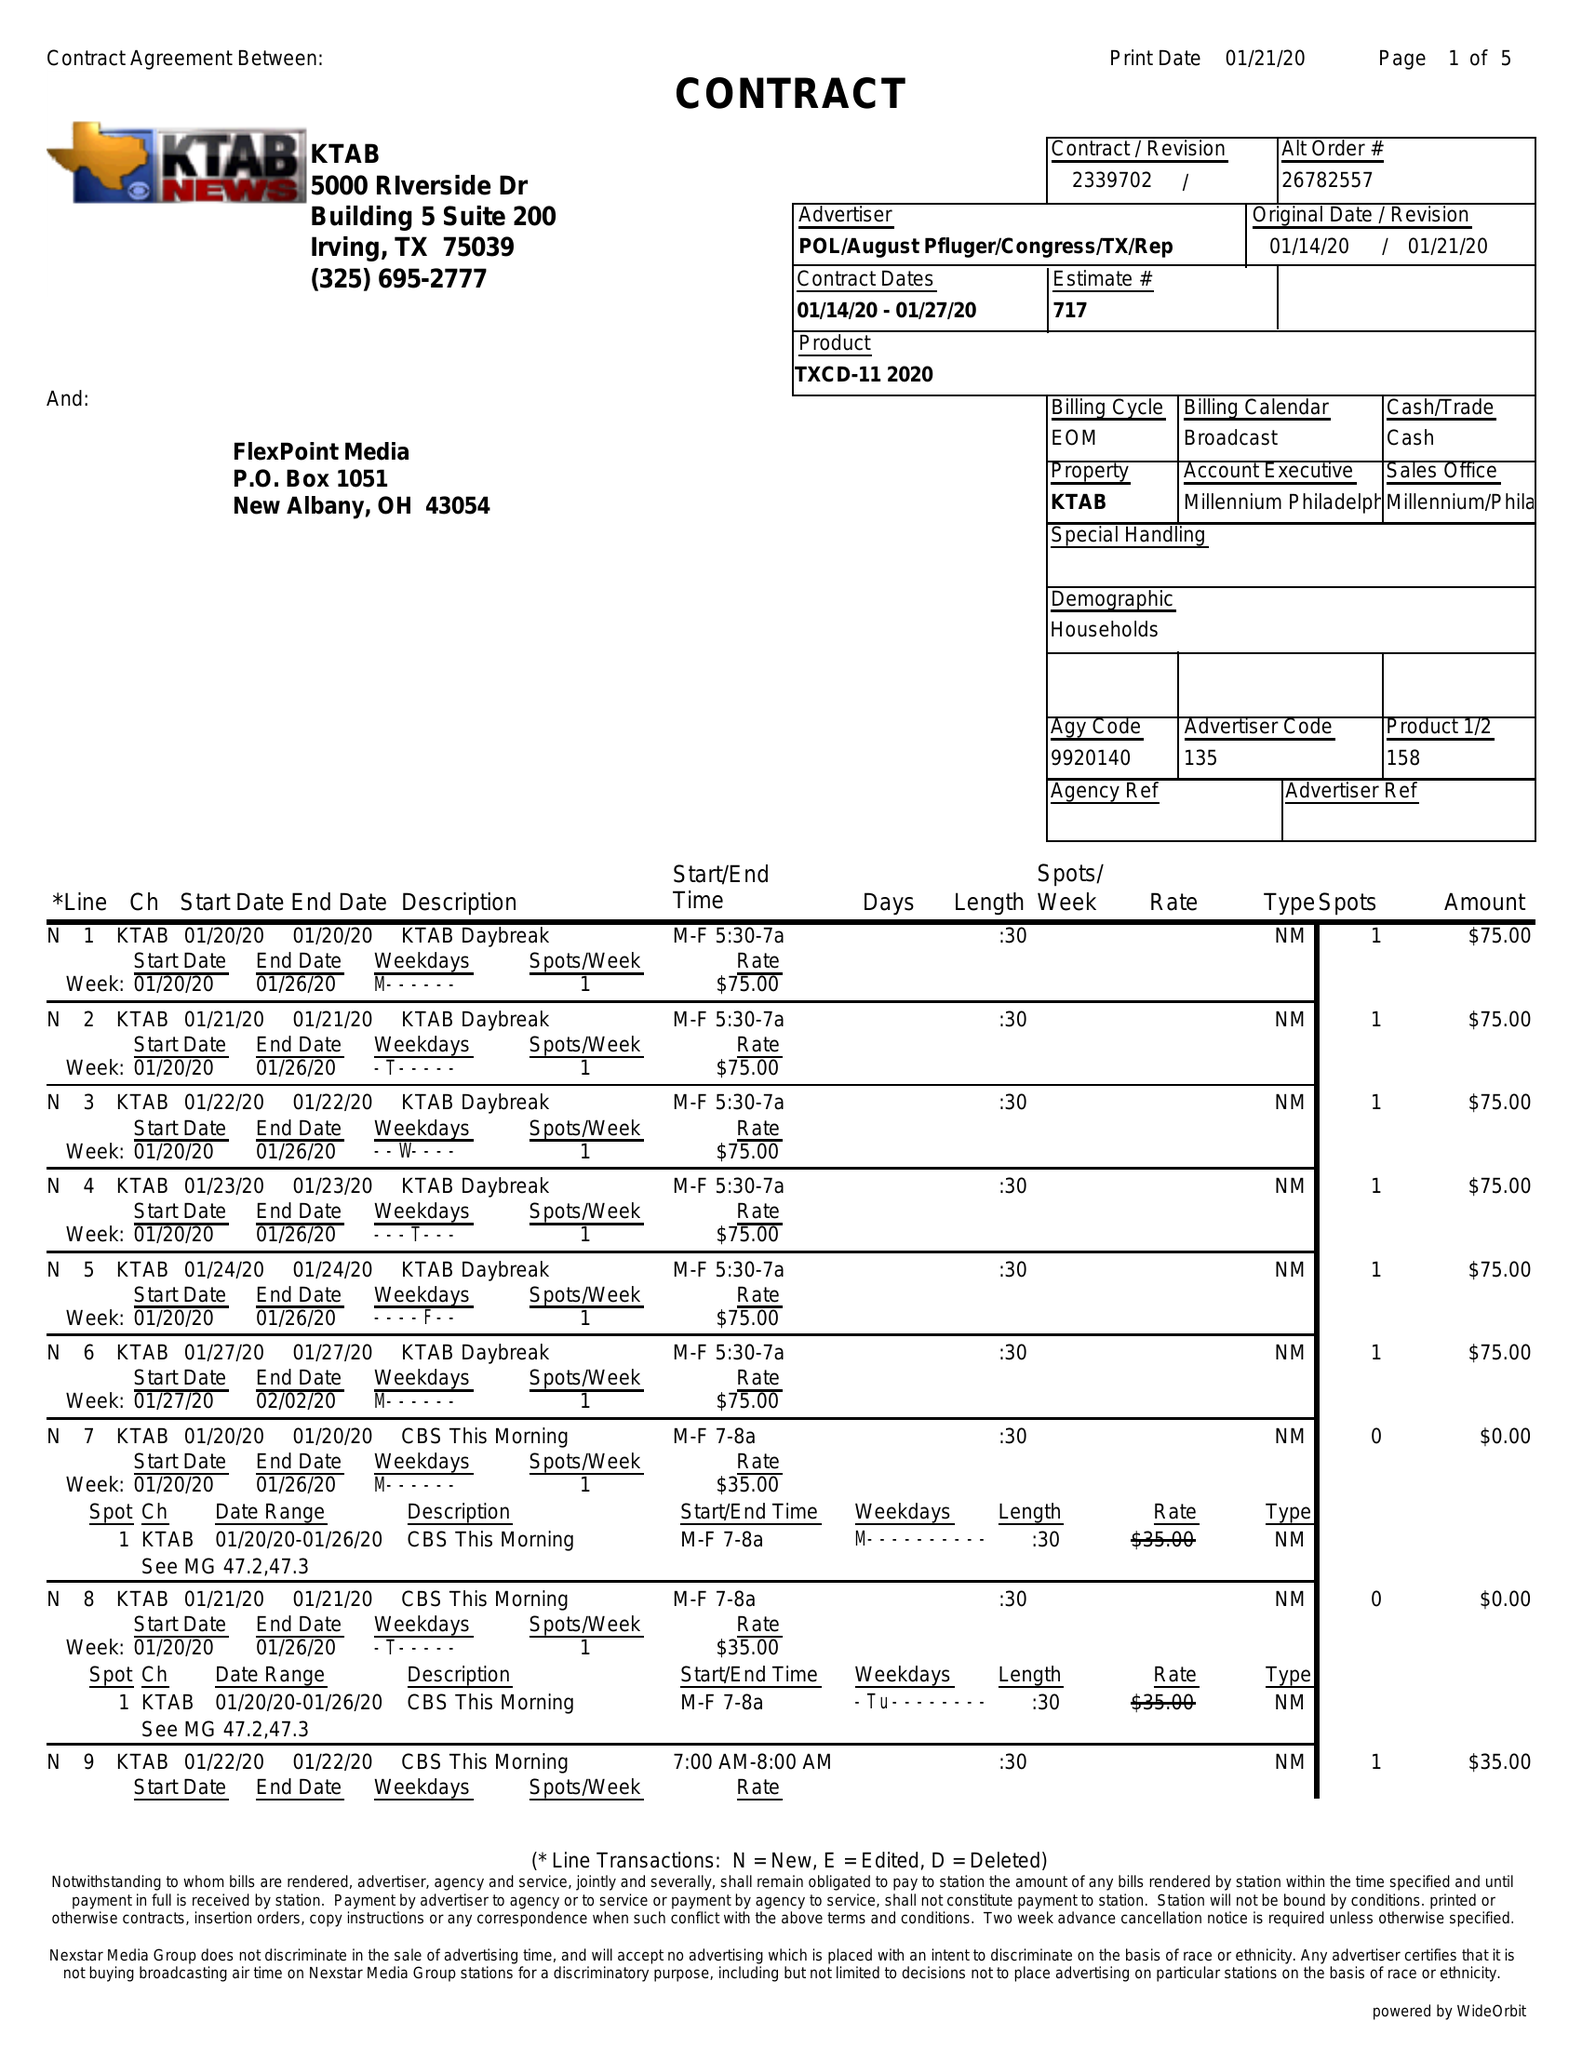What is the value for the flight_to?
Answer the question using a single word or phrase. 01/27/20 